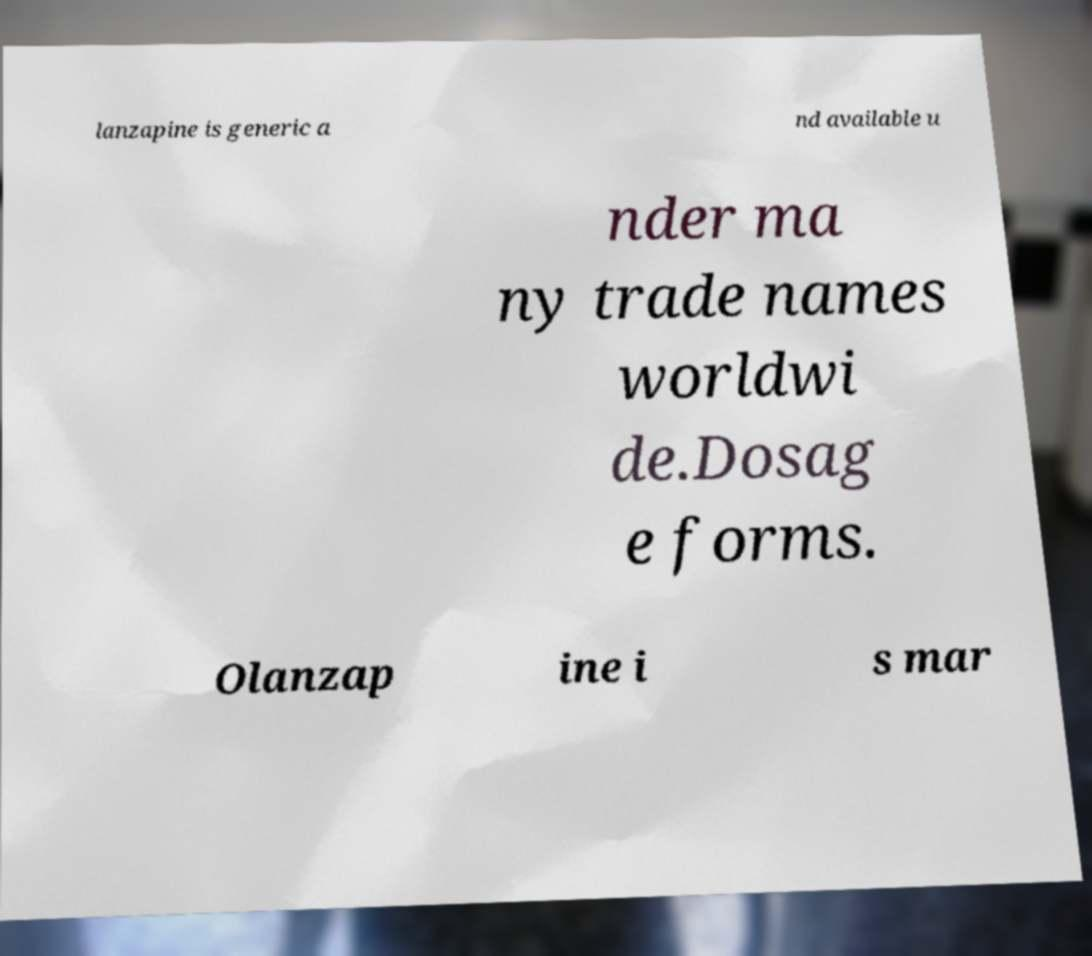There's text embedded in this image that I need extracted. Can you transcribe it verbatim? lanzapine is generic a nd available u nder ma ny trade names worldwi de.Dosag e forms. Olanzap ine i s mar 